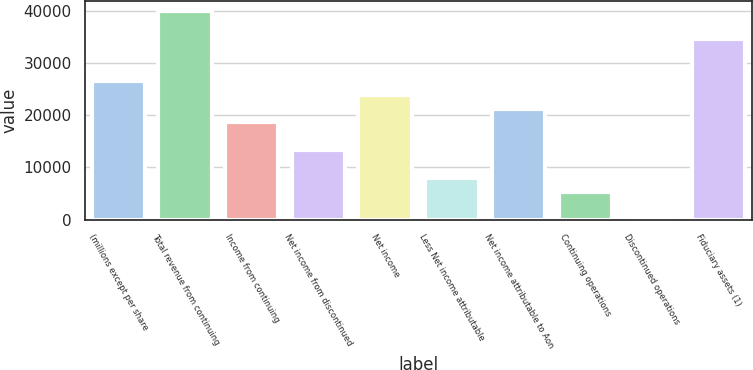<chart> <loc_0><loc_0><loc_500><loc_500><bar_chart><fcel>(millions except per share<fcel>Total revenue from continuing<fcel>Income from continuing<fcel>Net income from discontinued<fcel>Net income<fcel>Less Net income attributable<fcel>Net income attributable to Aon<fcel>Continuing operations<fcel>Discontinued operations<fcel>Fiduciary assets (1)<nl><fcel>26615<fcel>39922.1<fcel>18630.7<fcel>13307.8<fcel>23953.5<fcel>7984.95<fcel>21292.1<fcel>5323.52<fcel>0.66<fcel>34599.2<nl></chart> 